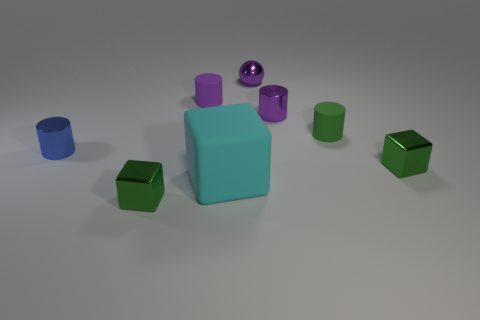Can you describe the lighting and shadows present in the scene? The lighting in the scene is soft and diffuse, coming from an overhead source. It creates gentle shadows on the ground beneath each object, indicating the light's direction. What can the presence of these shadows tell us about the objects? The shadows give us clues about the three-dimensional form of the objects, their placement in space, and the height and angle of the light source. 